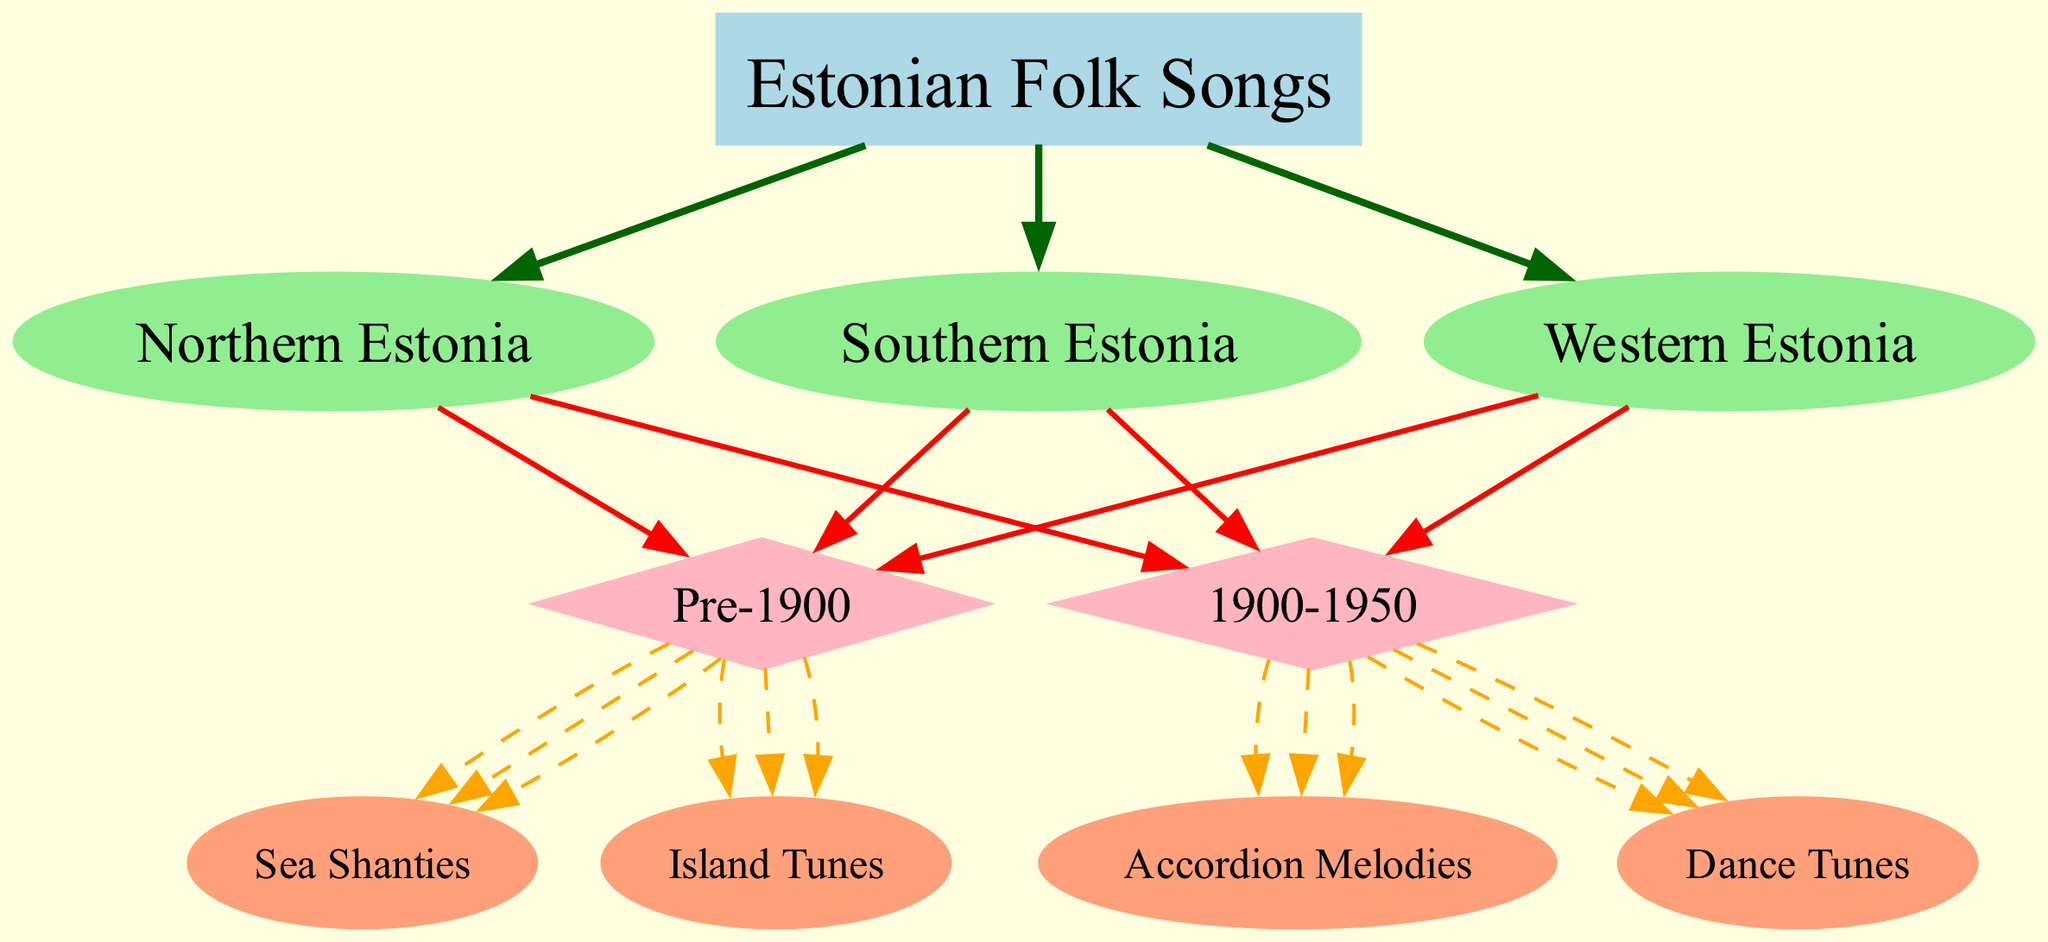What is the root node of the diagram? The root node is the starting point of the decision tree, which here is labeled "Estonian Folk Songs." It establishes the main category for all subsequent nodes and branches.
Answer: Estonian Folk Songs How many regions are there in the diagram? By examining the branches originating from the root node, we see there are three distinct regions represented: Northern Estonia, Southern Estonia, and Western Estonia.
Answer: 3 What types of songs are categorized under Northern Estonia for the era 1900-1950? Looking at the Northern Estonia branch, we find two types of songs noted for the era 1900-1950: "Patriotic Songs" and "Urban Ballads."
Answer: Patriotic Songs, Urban Ballads What is the leaf node corresponding to Southern Estonia and Pre-1900? Under the Southern Estonia branch, specifically within the Pre-1900 era, the leaf nodes identified are "Seto Leelo" and "Harvest Songs," which represent the types of songs from that time period and region.
Answer: Seto Leelo, Harvest Songs Which type of Estonian folk songs does the "sea shanties" belong to? The song type "Sea Shanties" can be traced back to the Western Estonia branch categorized under the Pre-1900 era, highlighting its specific regional and historical context.
Answer: Western Estonia, Pre-1900 How many total leaf nodes are present in the entire diagram? By counting the leaf nodes across all branches and eras, we find there are a total of six leaf nodes: "Regilaul," "Work Songs," "Patriotic Songs," "Urban Ballads," "Seto Leelo," "Harvest Songs," "Sea Shanties," "Island Tunes," "Accordion Melodies," and "Dance Tunes." Adding them gives a total of ten leaf nodes.
Answer: 10 Which era contains "Wedding Songs"? To find "Wedding Songs," we review the Southern Estonia branch in the diagram focused on the time period 1900-1950, confirming that it is classified under this era.
Answer: 1900-1950 What color represents the leaves in this diagram? Observing the visual representation in the diagram, the leaves are depicted in a light salmon color, distinguishing them as the endpoints that represent the final categories of Estonian folk songs.
Answer: Lightsalmon What type of diagram is this? This visual representation is structured as a decision tree, which is a specific methodology used in machine learning to categorize data based on tree-like diagrams.
Answer: Decision tree 